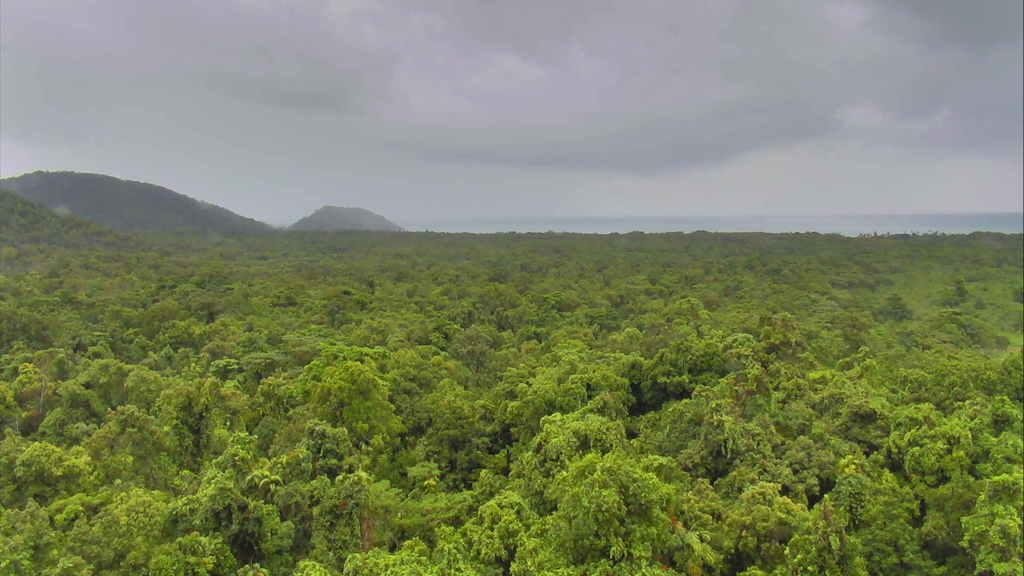What type of natural environment is depicted in the image? The image features plenty of trees, indicating a forest or wooded area. What geographical features can be seen in the background of the image? There are two mountains in the background of the image. What type of sponge can be seen floating in the river in the image? There is no river or sponge present in the image; it features trees and mountains. 